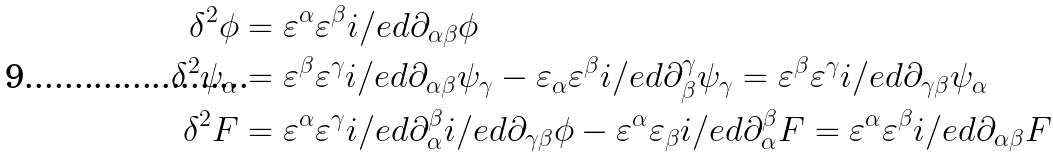Convert formula to latex. <formula><loc_0><loc_0><loc_500><loc_500>\delta ^ { 2 } \phi & = \varepsilon ^ { \alpha } \varepsilon ^ { \beta } i \slash e d { \partial } _ { \alpha \beta } \phi \\ \delta ^ { 2 } \psi _ { \alpha } & = \varepsilon ^ { \beta } \varepsilon ^ { \gamma } i \slash e d { \partial } _ { \alpha \beta } \psi _ { \gamma } - \varepsilon _ { \alpha } \varepsilon ^ { \beta } i \slash e d { \partial } _ { \beta } ^ { \gamma } \psi _ { \gamma } = \varepsilon ^ { \beta } \varepsilon ^ { \gamma } i \slash e d { \partial } _ { \gamma \beta } \psi _ { \alpha } \\ \delta ^ { 2 } F & = \varepsilon ^ { \alpha } \varepsilon ^ { \gamma } i \slash e d { \partial } _ { \alpha } ^ { \beta } i \slash e d { \partial } _ { \gamma \beta } \phi - \varepsilon ^ { \alpha } \varepsilon _ { \beta } i \slash e d { \partial } _ { \alpha } ^ { \beta } F = \varepsilon ^ { \alpha } \varepsilon ^ { \beta } i \slash e d { \partial } _ { \alpha \beta } F</formula> 